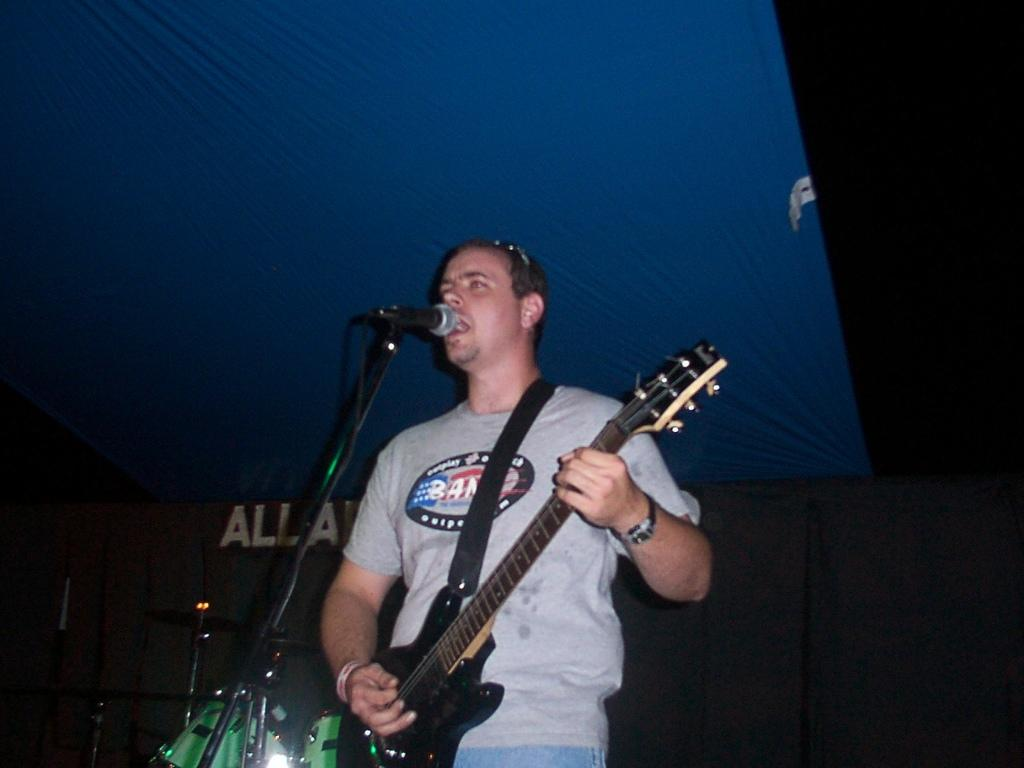What is the man in the image doing? The man is singing and playing a guitar in the image. What other objects related to music can be seen in the image? There are musical instruments in the image. What is the color of the cloth visible in the image? The color of the cloth is not specified in the facts, so we cannot determine its color. How would you describe the lighting in the image? The background of the image is dark. Can you see a river flowing in the background of the image? There is no mention of a river in the provided facts, so we cannot determine if a river is present in the image. 